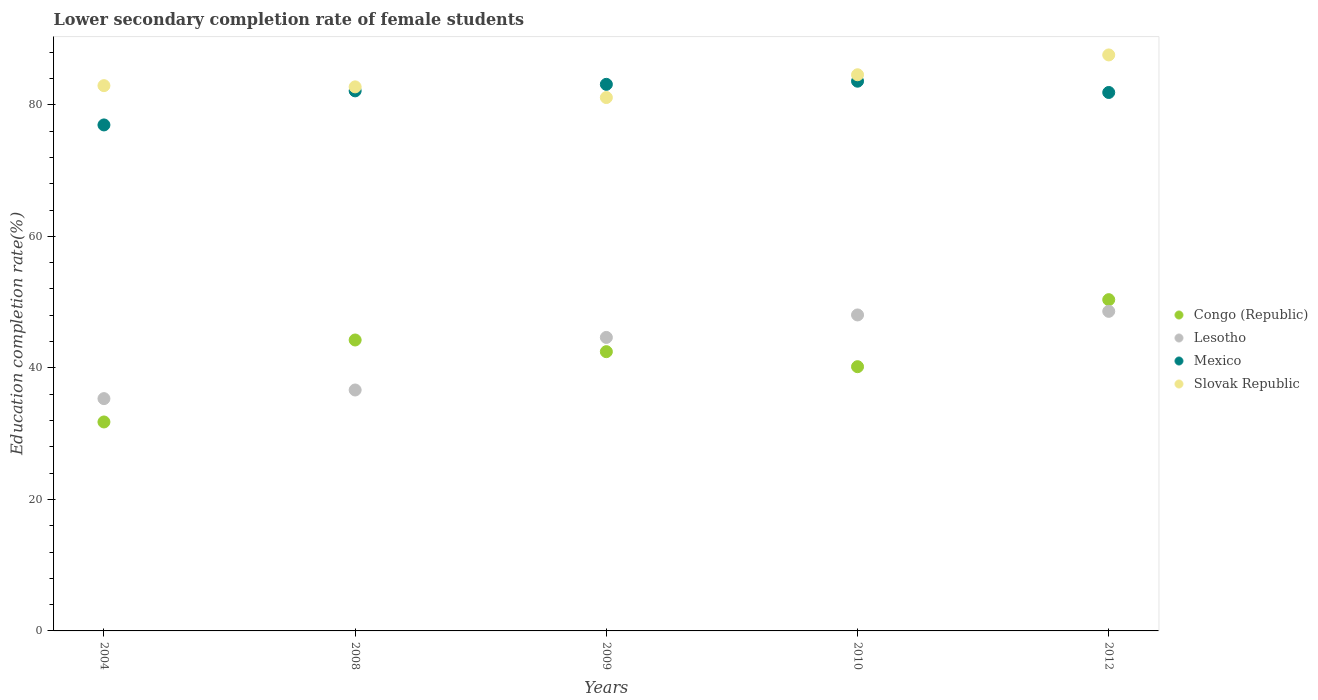Is the number of dotlines equal to the number of legend labels?
Offer a very short reply. Yes. What is the lower secondary completion rate of female students in Lesotho in 2012?
Your response must be concise. 48.6. Across all years, what is the maximum lower secondary completion rate of female students in Lesotho?
Offer a terse response. 48.6. Across all years, what is the minimum lower secondary completion rate of female students in Mexico?
Offer a very short reply. 76.94. In which year was the lower secondary completion rate of female students in Mexico maximum?
Provide a short and direct response. 2010. What is the total lower secondary completion rate of female students in Slovak Republic in the graph?
Provide a succinct answer. 418.91. What is the difference between the lower secondary completion rate of female students in Lesotho in 2004 and that in 2009?
Provide a succinct answer. -9.31. What is the difference between the lower secondary completion rate of female students in Lesotho in 2004 and the lower secondary completion rate of female students in Mexico in 2010?
Keep it short and to the point. -48.27. What is the average lower secondary completion rate of female students in Congo (Republic) per year?
Give a very brief answer. 41.81. In the year 2009, what is the difference between the lower secondary completion rate of female students in Mexico and lower secondary completion rate of female students in Slovak Republic?
Ensure brevity in your answer.  2.01. In how many years, is the lower secondary completion rate of female students in Congo (Republic) greater than 24 %?
Ensure brevity in your answer.  5. What is the ratio of the lower secondary completion rate of female students in Slovak Republic in 2004 to that in 2009?
Your response must be concise. 1.02. Is the difference between the lower secondary completion rate of female students in Mexico in 2009 and 2012 greater than the difference between the lower secondary completion rate of female students in Slovak Republic in 2009 and 2012?
Your answer should be very brief. Yes. What is the difference between the highest and the second highest lower secondary completion rate of female students in Mexico?
Keep it short and to the point. 0.48. What is the difference between the highest and the lowest lower secondary completion rate of female students in Lesotho?
Make the answer very short. 13.27. In how many years, is the lower secondary completion rate of female students in Congo (Republic) greater than the average lower secondary completion rate of female students in Congo (Republic) taken over all years?
Give a very brief answer. 3. Is the sum of the lower secondary completion rate of female students in Mexico in 2010 and 2012 greater than the maximum lower secondary completion rate of female students in Congo (Republic) across all years?
Ensure brevity in your answer.  Yes. Is it the case that in every year, the sum of the lower secondary completion rate of female students in Slovak Republic and lower secondary completion rate of female students in Mexico  is greater than the sum of lower secondary completion rate of female students in Congo (Republic) and lower secondary completion rate of female students in Lesotho?
Provide a short and direct response. No. Is it the case that in every year, the sum of the lower secondary completion rate of female students in Slovak Republic and lower secondary completion rate of female students in Lesotho  is greater than the lower secondary completion rate of female students in Congo (Republic)?
Provide a succinct answer. Yes. Does the lower secondary completion rate of female students in Lesotho monotonically increase over the years?
Your answer should be very brief. Yes. Is the lower secondary completion rate of female students in Slovak Republic strictly greater than the lower secondary completion rate of female students in Congo (Republic) over the years?
Give a very brief answer. Yes. Is the lower secondary completion rate of female students in Slovak Republic strictly less than the lower secondary completion rate of female students in Lesotho over the years?
Keep it short and to the point. No. How many years are there in the graph?
Ensure brevity in your answer.  5. What is the difference between two consecutive major ticks on the Y-axis?
Make the answer very short. 20. Does the graph contain any zero values?
Offer a very short reply. No. Where does the legend appear in the graph?
Offer a terse response. Center right. What is the title of the graph?
Your answer should be compact. Lower secondary completion rate of female students. Does "Least developed countries" appear as one of the legend labels in the graph?
Keep it short and to the point. No. What is the label or title of the X-axis?
Your response must be concise. Years. What is the label or title of the Y-axis?
Offer a very short reply. Education completion rate(%). What is the Education completion rate(%) in Congo (Republic) in 2004?
Offer a terse response. 31.77. What is the Education completion rate(%) in Lesotho in 2004?
Offer a terse response. 35.32. What is the Education completion rate(%) in Mexico in 2004?
Provide a short and direct response. 76.94. What is the Education completion rate(%) of Slovak Republic in 2004?
Provide a short and direct response. 82.92. What is the Education completion rate(%) in Congo (Republic) in 2008?
Give a very brief answer. 44.24. What is the Education completion rate(%) in Lesotho in 2008?
Provide a succinct answer. 36.64. What is the Education completion rate(%) in Mexico in 2008?
Ensure brevity in your answer.  82.12. What is the Education completion rate(%) of Slovak Republic in 2008?
Offer a terse response. 82.73. What is the Education completion rate(%) of Congo (Republic) in 2009?
Provide a succinct answer. 42.46. What is the Education completion rate(%) of Lesotho in 2009?
Your response must be concise. 44.63. What is the Education completion rate(%) in Mexico in 2009?
Make the answer very short. 83.12. What is the Education completion rate(%) of Slovak Republic in 2009?
Give a very brief answer. 81.11. What is the Education completion rate(%) in Congo (Republic) in 2010?
Ensure brevity in your answer.  40.18. What is the Education completion rate(%) in Lesotho in 2010?
Provide a succinct answer. 48.05. What is the Education completion rate(%) of Mexico in 2010?
Keep it short and to the point. 83.59. What is the Education completion rate(%) in Slovak Republic in 2010?
Your answer should be compact. 84.57. What is the Education completion rate(%) of Congo (Republic) in 2012?
Your response must be concise. 50.37. What is the Education completion rate(%) of Lesotho in 2012?
Your answer should be very brief. 48.6. What is the Education completion rate(%) in Mexico in 2012?
Your response must be concise. 81.88. What is the Education completion rate(%) of Slovak Republic in 2012?
Give a very brief answer. 87.59. Across all years, what is the maximum Education completion rate(%) in Congo (Republic)?
Offer a terse response. 50.37. Across all years, what is the maximum Education completion rate(%) of Lesotho?
Provide a short and direct response. 48.6. Across all years, what is the maximum Education completion rate(%) in Mexico?
Ensure brevity in your answer.  83.59. Across all years, what is the maximum Education completion rate(%) of Slovak Republic?
Your answer should be compact. 87.59. Across all years, what is the minimum Education completion rate(%) of Congo (Republic)?
Keep it short and to the point. 31.77. Across all years, what is the minimum Education completion rate(%) of Lesotho?
Keep it short and to the point. 35.32. Across all years, what is the minimum Education completion rate(%) of Mexico?
Provide a short and direct response. 76.94. Across all years, what is the minimum Education completion rate(%) in Slovak Republic?
Keep it short and to the point. 81.11. What is the total Education completion rate(%) of Congo (Republic) in the graph?
Make the answer very short. 209.03. What is the total Education completion rate(%) of Lesotho in the graph?
Offer a terse response. 213.24. What is the total Education completion rate(%) in Mexico in the graph?
Provide a short and direct response. 407.65. What is the total Education completion rate(%) in Slovak Republic in the graph?
Offer a terse response. 418.91. What is the difference between the Education completion rate(%) in Congo (Republic) in 2004 and that in 2008?
Offer a very short reply. -12.47. What is the difference between the Education completion rate(%) of Lesotho in 2004 and that in 2008?
Give a very brief answer. -1.31. What is the difference between the Education completion rate(%) in Mexico in 2004 and that in 2008?
Ensure brevity in your answer.  -5.18. What is the difference between the Education completion rate(%) of Slovak Republic in 2004 and that in 2008?
Keep it short and to the point. 0.19. What is the difference between the Education completion rate(%) in Congo (Republic) in 2004 and that in 2009?
Offer a very short reply. -10.69. What is the difference between the Education completion rate(%) in Lesotho in 2004 and that in 2009?
Ensure brevity in your answer.  -9.31. What is the difference between the Education completion rate(%) in Mexico in 2004 and that in 2009?
Provide a succinct answer. -6.17. What is the difference between the Education completion rate(%) in Slovak Republic in 2004 and that in 2009?
Your answer should be compact. 1.81. What is the difference between the Education completion rate(%) of Congo (Republic) in 2004 and that in 2010?
Your response must be concise. -8.4. What is the difference between the Education completion rate(%) in Lesotho in 2004 and that in 2010?
Ensure brevity in your answer.  -12.72. What is the difference between the Education completion rate(%) of Mexico in 2004 and that in 2010?
Give a very brief answer. -6.65. What is the difference between the Education completion rate(%) in Slovak Republic in 2004 and that in 2010?
Offer a very short reply. -1.66. What is the difference between the Education completion rate(%) in Congo (Republic) in 2004 and that in 2012?
Your answer should be compact. -18.6. What is the difference between the Education completion rate(%) in Lesotho in 2004 and that in 2012?
Keep it short and to the point. -13.27. What is the difference between the Education completion rate(%) in Mexico in 2004 and that in 2012?
Offer a very short reply. -4.94. What is the difference between the Education completion rate(%) of Slovak Republic in 2004 and that in 2012?
Make the answer very short. -4.67. What is the difference between the Education completion rate(%) in Congo (Republic) in 2008 and that in 2009?
Your answer should be very brief. 1.78. What is the difference between the Education completion rate(%) of Lesotho in 2008 and that in 2009?
Offer a terse response. -7.99. What is the difference between the Education completion rate(%) of Mexico in 2008 and that in 2009?
Make the answer very short. -0.99. What is the difference between the Education completion rate(%) of Slovak Republic in 2008 and that in 2009?
Offer a terse response. 1.62. What is the difference between the Education completion rate(%) of Congo (Republic) in 2008 and that in 2010?
Offer a very short reply. 4.06. What is the difference between the Education completion rate(%) of Lesotho in 2008 and that in 2010?
Keep it short and to the point. -11.41. What is the difference between the Education completion rate(%) in Mexico in 2008 and that in 2010?
Make the answer very short. -1.47. What is the difference between the Education completion rate(%) of Slovak Republic in 2008 and that in 2010?
Your answer should be compact. -1.84. What is the difference between the Education completion rate(%) of Congo (Republic) in 2008 and that in 2012?
Your response must be concise. -6.13. What is the difference between the Education completion rate(%) of Lesotho in 2008 and that in 2012?
Provide a succinct answer. -11.96. What is the difference between the Education completion rate(%) of Mexico in 2008 and that in 2012?
Your answer should be very brief. 0.24. What is the difference between the Education completion rate(%) in Slovak Republic in 2008 and that in 2012?
Offer a very short reply. -4.86. What is the difference between the Education completion rate(%) in Congo (Republic) in 2009 and that in 2010?
Offer a very short reply. 2.28. What is the difference between the Education completion rate(%) of Lesotho in 2009 and that in 2010?
Make the answer very short. -3.42. What is the difference between the Education completion rate(%) in Mexico in 2009 and that in 2010?
Your response must be concise. -0.48. What is the difference between the Education completion rate(%) of Slovak Republic in 2009 and that in 2010?
Give a very brief answer. -3.47. What is the difference between the Education completion rate(%) in Congo (Republic) in 2009 and that in 2012?
Your response must be concise. -7.91. What is the difference between the Education completion rate(%) in Lesotho in 2009 and that in 2012?
Your response must be concise. -3.97. What is the difference between the Education completion rate(%) of Mexico in 2009 and that in 2012?
Your answer should be compact. 1.24. What is the difference between the Education completion rate(%) of Slovak Republic in 2009 and that in 2012?
Provide a succinct answer. -6.48. What is the difference between the Education completion rate(%) of Congo (Republic) in 2010 and that in 2012?
Keep it short and to the point. -10.19. What is the difference between the Education completion rate(%) in Lesotho in 2010 and that in 2012?
Ensure brevity in your answer.  -0.55. What is the difference between the Education completion rate(%) of Mexico in 2010 and that in 2012?
Your answer should be compact. 1.72. What is the difference between the Education completion rate(%) of Slovak Republic in 2010 and that in 2012?
Your response must be concise. -3.01. What is the difference between the Education completion rate(%) of Congo (Republic) in 2004 and the Education completion rate(%) of Lesotho in 2008?
Provide a succinct answer. -4.86. What is the difference between the Education completion rate(%) of Congo (Republic) in 2004 and the Education completion rate(%) of Mexico in 2008?
Your answer should be compact. -50.35. What is the difference between the Education completion rate(%) of Congo (Republic) in 2004 and the Education completion rate(%) of Slovak Republic in 2008?
Your answer should be compact. -50.96. What is the difference between the Education completion rate(%) of Lesotho in 2004 and the Education completion rate(%) of Mexico in 2008?
Provide a succinct answer. -46.8. What is the difference between the Education completion rate(%) in Lesotho in 2004 and the Education completion rate(%) in Slovak Republic in 2008?
Offer a terse response. -47.41. What is the difference between the Education completion rate(%) in Mexico in 2004 and the Education completion rate(%) in Slovak Republic in 2008?
Give a very brief answer. -5.79. What is the difference between the Education completion rate(%) of Congo (Republic) in 2004 and the Education completion rate(%) of Lesotho in 2009?
Your answer should be very brief. -12.85. What is the difference between the Education completion rate(%) in Congo (Republic) in 2004 and the Education completion rate(%) in Mexico in 2009?
Give a very brief answer. -51.34. What is the difference between the Education completion rate(%) of Congo (Republic) in 2004 and the Education completion rate(%) of Slovak Republic in 2009?
Offer a very short reply. -49.33. What is the difference between the Education completion rate(%) of Lesotho in 2004 and the Education completion rate(%) of Mexico in 2009?
Your answer should be compact. -47.79. What is the difference between the Education completion rate(%) of Lesotho in 2004 and the Education completion rate(%) of Slovak Republic in 2009?
Your answer should be very brief. -45.78. What is the difference between the Education completion rate(%) of Mexico in 2004 and the Education completion rate(%) of Slovak Republic in 2009?
Offer a terse response. -4.16. What is the difference between the Education completion rate(%) in Congo (Republic) in 2004 and the Education completion rate(%) in Lesotho in 2010?
Give a very brief answer. -16.27. What is the difference between the Education completion rate(%) in Congo (Republic) in 2004 and the Education completion rate(%) in Mexico in 2010?
Ensure brevity in your answer.  -51.82. What is the difference between the Education completion rate(%) in Congo (Republic) in 2004 and the Education completion rate(%) in Slovak Republic in 2010?
Ensure brevity in your answer.  -52.8. What is the difference between the Education completion rate(%) in Lesotho in 2004 and the Education completion rate(%) in Mexico in 2010?
Provide a short and direct response. -48.27. What is the difference between the Education completion rate(%) in Lesotho in 2004 and the Education completion rate(%) in Slovak Republic in 2010?
Offer a very short reply. -49.25. What is the difference between the Education completion rate(%) of Mexico in 2004 and the Education completion rate(%) of Slovak Republic in 2010?
Offer a terse response. -7.63. What is the difference between the Education completion rate(%) in Congo (Republic) in 2004 and the Education completion rate(%) in Lesotho in 2012?
Ensure brevity in your answer.  -16.82. What is the difference between the Education completion rate(%) of Congo (Republic) in 2004 and the Education completion rate(%) of Mexico in 2012?
Offer a very short reply. -50.1. What is the difference between the Education completion rate(%) of Congo (Republic) in 2004 and the Education completion rate(%) of Slovak Republic in 2012?
Provide a short and direct response. -55.81. What is the difference between the Education completion rate(%) in Lesotho in 2004 and the Education completion rate(%) in Mexico in 2012?
Make the answer very short. -46.55. What is the difference between the Education completion rate(%) in Lesotho in 2004 and the Education completion rate(%) in Slovak Republic in 2012?
Your answer should be very brief. -52.26. What is the difference between the Education completion rate(%) in Mexico in 2004 and the Education completion rate(%) in Slovak Republic in 2012?
Offer a very short reply. -10.65. What is the difference between the Education completion rate(%) in Congo (Republic) in 2008 and the Education completion rate(%) in Lesotho in 2009?
Provide a succinct answer. -0.39. What is the difference between the Education completion rate(%) of Congo (Republic) in 2008 and the Education completion rate(%) of Mexico in 2009?
Your answer should be very brief. -38.88. What is the difference between the Education completion rate(%) in Congo (Republic) in 2008 and the Education completion rate(%) in Slovak Republic in 2009?
Give a very brief answer. -36.87. What is the difference between the Education completion rate(%) of Lesotho in 2008 and the Education completion rate(%) of Mexico in 2009?
Provide a succinct answer. -46.48. What is the difference between the Education completion rate(%) of Lesotho in 2008 and the Education completion rate(%) of Slovak Republic in 2009?
Your response must be concise. -44.47. What is the difference between the Education completion rate(%) of Mexico in 2008 and the Education completion rate(%) of Slovak Republic in 2009?
Offer a terse response. 1.01. What is the difference between the Education completion rate(%) in Congo (Republic) in 2008 and the Education completion rate(%) in Lesotho in 2010?
Your answer should be very brief. -3.81. What is the difference between the Education completion rate(%) of Congo (Republic) in 2008 and the Education completion rate(%) of Mexico in 2010?
Your answer should be very brief. -39.35. What is the difference between the Education completion rate(%) in Congo (Republic) in 2008 and the Education completion rate(%) in Slovak Republic in 2010?
Make the answer very short. -40.33. What is the difference between the Education completion rate(%) of Lesotho in 2008 and the Education completion rate(%) of Mexico in 2010?
Give a very brief answer. -46.96. What is the difference between the Education completion rate(%) of Lesotho in 2008 and the Education completion rate(%) of Slovak Republic in 2010?
Ensure brevity in your answer.  -47.94. What is the difference between the Education completion rate(%) in Mexico in 2008 and the Education completion rate(%) in Slovak Republic in 2010?
Give a very brief answer. -2.45. What is the difference between the Education completion rate(%) in Congo (Republic) in 2008 and the Education completion rate(%) in Lesotho in 2012?
Provide a short and direct response. -4.36. What is the difference between the Education completion rate(%) in Congo (Republic) in 2008 and the Education completion rate(%) in Mexico in 2012?
Make the answer very short. -37.64. What is the difference between the Education completion rate(%) in Congo (Republic) in 2008 and the Education completion rate(%) in Slovak Republic in 2012?
Offer a terse response. -43.35. What is the difference between the Education completion rate(%) of Lesotho in 2008 and the Education completion rate(%) of Mexico in 2012?
Provide a short and direct response. -45.24. What is the difference between the Education completion rate(%) in Lesotho in 2008 and the Education completion rate(%) in Slovak Republic in 2012?
Your answer should be very brief. -50.95. What is the difference between the Education completion rate(%) of Mexico in 2008 and the Education completion rate(%) of Slovak Republic in 2012?
Offer a terse response. -5.47. What is the difference between the Education completion rate(%) in Congo (Republic) in 2009 and the Education completion rate(%) in Lesotho in 2010?
Your answer should be very brief. -5.59. What is the difference between the Education completion rate(%) in Congo (Republic) in 2009 and the Education completion rate(%) in Mexico in 2010?
Provide a succinct answer. -41.13. What is the difference between the Education completion rate(%) of Congo (Republic) in 2009 and the Education completion rate(%) of Slovak Republic in 2010?
Give a very brief answer. -42.11. What is the difference between the Education completion rate(%) of Lesotho in 2009 and the Education completion rate(%) of Mexico in 2010?
Keep it short and to the point. -38.96. What is the difference between the Education completion rate(%) of Lesotho in 2009 and the Education completion rate(%) of Slovak Republic in 2010?
Keep it short and to the point. -39.94. What is the difference between the Education completion rate(%) of Mexico in 2009 and the Education completion rate(%) of Slovak Republic in 2010?
Provide a short and direct response. -1.46. What is the difference between the Education completion rate(%) in Congo (Republic) in 2009 and the Education completion rate(%) in Lesotho in 2012?
Offer a very short reply. -6.13. What is the difference between the Education completion rate(%) in Congo (Republic) in 2009 and the Education completion rate(%) in Mexico in 2012?
Provide a short and direct response. -39.41. What is the difference between the Education completion rate(%) in Congo (Republic) in 2009 and the Education completion rate(%) in Slovak Republic in 2012?
Make the answer very short. -45.12. What is the difference between the Education completion rate(%) in Lesotho in 2009 and the Education completion rate(%) in Mexico in 2012?
Your answer should be very brief. -37.25. What is the difference between the Education completion rate(%) in Lesotho in 2009 and the Education completion rate(%) in Slovak Republic in 2012?
Provide a short and direct response. -42.96. What is the difference between the Education completion rate(%) in Mexico in 2009 and the Education completion rate(%) in Slovak Republic in 2012?
Your response must be concise. -4.47. What is the difference between the Education completion rate(%) in Congo (Republic) in 2010 and the Education completion rate(%) in Lesotho in 2012?
Ensure brevity in your answer.  -8.42. What is the difference between the Education completion rate(%) in Congo (Republic) in 2010 and the Education completion rate(%) in Mexico in 2012?
Your response must be concise. -41.7. What is the difference between the Education completion rate(%) of Congo (Republic) in 2010 and the Education completion rate(%) of Slovak Republic in 2012?
Keep it short and to the point. -47.41. What is the difference between the Education completion rate(%) in Lesotho in 2010 and the Education completion rate(%) in Mexico in 2012?
Your response must be concise. -33.83. What is the difference between the Education completion rate(%) in Lesotho in 2010 and the Education completion rate(%) in Slovak Republic in 2012?
Your response must be concise. -39.54. What is the difference between the Education completion rate(%) of Mexico in 2010 and the Education completion rate(%) of Slovak Republic in 2012?
Give a very brief answer. -3.99. What is the average Education completion rate(%) of Congo (Republic) per year?
Provide a short and direct response. 41.81. What is the average Education completion rate(%) in Lesotho per year?
Your answer should be compact. 42.65. What is the average Education completion rate(%) of Mexico per year?
Provide a short and direct response. 81.53. What is the average Education completion rate(%) in Slovak Republic per year?
Offer a very short reply. 83.78. In the year 2004, what is the difference between the Education completion rate(%) of Congo (Republic) and Education completion rate(%) of Lesotho?
Keep it short and to the point. -3.55. In the year 2004, what is the difference between the Education completion rate(%) in Congo (Republic) and Education completion rate(%) in Mexico?
Offer a very short reply. -45.17. In the year 2004, what is the difference between the Education completion rate(%) in Congo (Republic) and Education completion rate(%) in Slovak Republic?
Provide a short and direct response. -51.14. In the year 2004, what is the difference between the Education completion rate(%) in Lesotho and Education completion rate(%) in Mexico?
Offer a very short reply. -41.62. In the year 2004, what is the difference between the Education completion rate(%) in Lesotho and Education completion rate(%) in Slovak Republic?
Give a very brief answer. -47.59. In the year 2004, what is the difference between the Education completion rate(%) in Mexico and Education completion rate(%) in Slovak Republic?
Offer a terse response. -5.97. In the year 2008, what is the difference between the Education completion rate(%) in Congo (Republic) and Education completion rate(%) in Lesotho?
Provide a succinct answer. 7.6. In the year 2008, what is the difference between the Education completion rate(%) in Congo (Republic) and Education completion rate(%) in Mexico?
Make the answer very short. -37.88. In the year 2008, what is the difference between the Education completion rate(%) of Congo (Republic) and Education completion rate(%) of Slovak Republic?
Ensure brevity in your answer.  -38.49. In the year 2008, what is the difference between the Education completion rate(%) of Lesotho and Education completion rate(%) of Mexico?
Your answer should be compact. -45.48. In the year 2008, what is the difference between the Education completion rate(%) in Lesotho and Education completion rate(%) in Slovak Republic?
Give a very brief answer. -46.09. In the year 2008, what is the difference between the Education completion rate(%) in Mexico and Education completion rate(%) in Slovak Republic?
Your answer should be compact. -0.61. In the year 2009, what is the difference between the Education completion rate(%) in Congo (Republic) and Education completion rate(%) in Lesotho?
Offer a terse response. -2.17. In the year 2009, what is the difference between the Education completion rate(%) in Congo (Republic) and Education completion rate(%) in Mexico?
Offer a terse response. -40.65. In the year 2009, what is the difference between the Education completion rate(%) in Congo (Republic) and Education completion rate(%) in Slovak Republic?
Provide a succinct answer. -38.64. In the year 2009, what is the difference between the Education completion rate(%) of Lesotho and Education completion rate(%) of Mexico?
Give a very brief answer. -38.49. In the year 2009, what is the difference between the Education completion rate(%) of Lesotho and Education completion rate(%) of Slovak Republic?
Make the answer very short. -36.48. In the year 2009, what is the difference between the Education completion rate(%) of Mexico and Education completion rate(%) of Slovak Republic?
Your response must be concise. 2.01. In the year 2010, what is the difference between the Education completion rate(%) in Congo (Republic) and Education completion rate(%) in Lesotho?
Your response must be concise. -7.87. In the year 2010, what is the difference between the Education completion rate(%) in Congo (Republic) and Education completion rate(%) in Mexico?
Offer a very short reply. -43.41. In the year 2010, what is the difference between the Education completion rate(%) of Congo (Republic) and Education completion rate(%) of Slovak Republic?
Your answer should be very brief. -44.39. In the year 2010, what is the difference between the Education completion rate(%) of Lesotho and Education completion rate(%) of Mexico?
Offer a very short reply. -35.54. In the year 2010, what is the difference between the Education completion rate(%) of Lesotho and Education completion rate(%) of Slovak Republic?
Provide a succinct answer. -36.52. In the year 2010, what is the difference between the Education completion rate(%) of Mexico and Education completion rate(%) of Slovak Republic?
Offer a terse response. -0.98. In the year 2012, what is the difference between the Education completion rate(%) in Congo (Republic) and Education completion rate(%) in Lesotho?
Your answer should be compact. 1.77. In the year 2012, what is the difference between the Education completion rate(%) of Congo (Republic) and Education completion rate(%) of Mexico?
Ensure brevity in your answer.  -31.51. In the year 2012, what is the difference between the Education completion rate(%) of Congo (Republic) and Education completion rate(%) of Slovak Republic?
Offer a very short reply. -37.22. In the year 2012, what is the difference between the Education completion rate(%) of Lesotho and Education completion rate(%) of Mexico?
Your answer should be very brief. -33.28. In the year 2012, what is the difference between the Education completion rate(%) in Lesotho and Education completion rate(%) in Slovak Republic?
Make the answer very short. -38.99. In the year 2012, what is the difference between the Education completion rate(%) of Mexico and Education completion rate(%) of Slovak Republic?
Provide a short and direct response. -5.71. What is the ratio of the Education completion rate(%) in Congo (Republic) in 2004 to that in 2008?
Your answer should be compact. 0.72. What is the ratio of the Education completion rate(%) in Lesotho in 2004 to that in 2008?
Your answer should be very brief. 0.96. What is the ratio of the Education completion rate(%) in Mexico in 2004 to that in 2008?
Give a very brief answer. 0.94. What is the ratio of the Education completion rate(%) of Slovak Republic in 2004 to that in 2008?
Offer a very short reply. 1. What is the ratio of the Education completion rate(%) of Congo (Republic) in 2004 to that in 2009?
Provide a succinct answer. 0.75. What is the ratio of the Education completion rate(%) of Lesotho in 2004 to that in 2009?
Keep it short and to the point. 0.79. What is the ratio of the Education completion rate(%) of Mexico in 2004 to that in 2009?
Ensure brevity in your answer.  0.93. What is the ratio of the Education completion rate(%) in Slovak Republic in 2004 to that in 2009?
Your answer should be compact. 1.02. What is the ratio of the Education completion rate(%) of Congo (Republic) in 2004 to that in 2010?
Provide a short and direct response. 0.79. What is the ratio of the Education completion rate(%) of Lesotho in 2004 to that in 2010?
Your response must be concise. 0.74. What is the ratio of the Education completion rate(%) of Mexico in 2004 to that in 2010?
Offer a very short reply. 0.92. What is the ratio of the Education completion rate(%) in Slovak Republic in 2004 to that in 2010?
Give a very brief answer. 0.98. What is the ratio of the Education completion rate(%) in Congo (Republic) in 2004 to that in 2012?
Make the answer very short. 0.63. What is the ratio of the Education completion rate(%) in Lesotho in 2004 to that in 2012?
Offer a terse response. 0.73. What is the ratio of the Education completion rate(%) in Mexico in 2004 to that in 2012?
Give a very brief answer. 0.94. What is the ratio of the Education completion rate(%) of Slovak Republic in 2004 to that in 2012?
Your response must be concise. 0.95. What is the ratio of the Education completion rate(%) in Congo (Republic) in 2008 to that in 2009?
Keep it short and to the point. 1.04. What is the ratio of the Education completion rate(%) in Lesotho in 2008 to that in 2009?
Keep it short and to the point. 0.82. What is the ratio of the Education completion rate(%) of Mexico in 2008 to that in 2009?
Provide a short and direct response. 0.99. What is the ratio of the Education completion rate(%) in Congo (Republic) in 2008 to that in 2010?
Give a very brief answer. 1.1. What is the ratio of the Education completion rate(%) of Lesotho in 2008 to that in 2010?
Provide a succinct answer. 0.76. What is the ratio of the Education completion rate(%) of Mexico in 2008 to that in 2010?
Your response must be concise. 0.98. What is the ratio of the Education completion rate(%) in Slovak Republic in 2008 to that in 2010?
Your response must be concise. 0.98. What is the ratio of the Education completion rate(%) in Congo (Republic) in 2008 to that in 2012?
Ensure brevity in your answer.  0.88. What is the ratio of the Education completion rate(%) in Lesotho in 2008 to that in 2012?
Keep it short and to the point. 0.75. What is the ratio of the Education completion rate(%) in Mexico in 2008 to that in 2012?
Offer a terse response. 1. What is the ratio of the Education completion rate(%) of Slovak Republic in 2008 to that in 2012?
Offer a terse response. 0.94. What is the ratio of the Education completion rate(%) in Congo (Republic) in 2009 to that in 2010?
Offer a very short reply. 1.06. What is the ratio of the Education completion rate(%) of Lesotho in 2009 to that in 2010?
Give a very brief answer. 0.93. What is the ratio of the Education completion rate(%) in Slovak Republic in 2009 to that in 2010?
Your answer should be compact. 0.96. What is the ratio of the Education completion rate(%) of Congo (Republic) in 2009 to that in 2012?
Offer a terse response. 0.84. What is the ratio of the Education completion rate(%) in Lesotho in 2009 to that in 2012?
Your response must be concise. 0.92. What is the ratio of the Education completion rate(%) of Mexico in 2009 to that in 2012?
Offer a very short reply. 1.02. What is the ratio of the Education completion rate(%) of Slovak Republic in 2009 to that in 2012?
Your response must be concise. 0.93. What is the ratio of the Education completion rate(%) in Congo (Republic) in 2010 to that in 2012?
Give a very brief answer. 0.8. What is the ratio of the Education completion rate(%) in Lesotho in 2010 to that in 2012?
Make the answer very short. 0.99. What is the ratio of the Education completion rate(%) in Slovak Republic in 2010 to that in 2012?
Keep it short and to the point. 0.97. What is the difference between the highest and the second highest Education completion rate(%) of Congo (Republic)?
Offer a terse response. 6.13. What is the difference between the highest and the second highest Education completion rate(%) in Lesotho?
Provide a short and direct response. 0.55. What is the difference between the highest and the second highest Education completion rate(%) of Mexico?
Your answer should be very brief. 0.48. What is the difference between the highest and the second highest Education completion rate(%) in Slovak Republic?
Make the answer very short. 3.01. What is the difference between the highest and the lowest Education completion rate(%) of Congo (Republic)?
Provide a short and direct response. 18.6. What is the difference between the highest and the lowest Education completion rate(%) in Lesotho?
Your answer should be compact. 13.27. What is the difference between the highest and the lowest Education completion rate(%) of Mexico?
Offer a terse response. 6.65. What is the difference between the highest and the lowest Education completion rate(%) in Slovak Republic?
Ensure brevity in your answer.  6.48. 